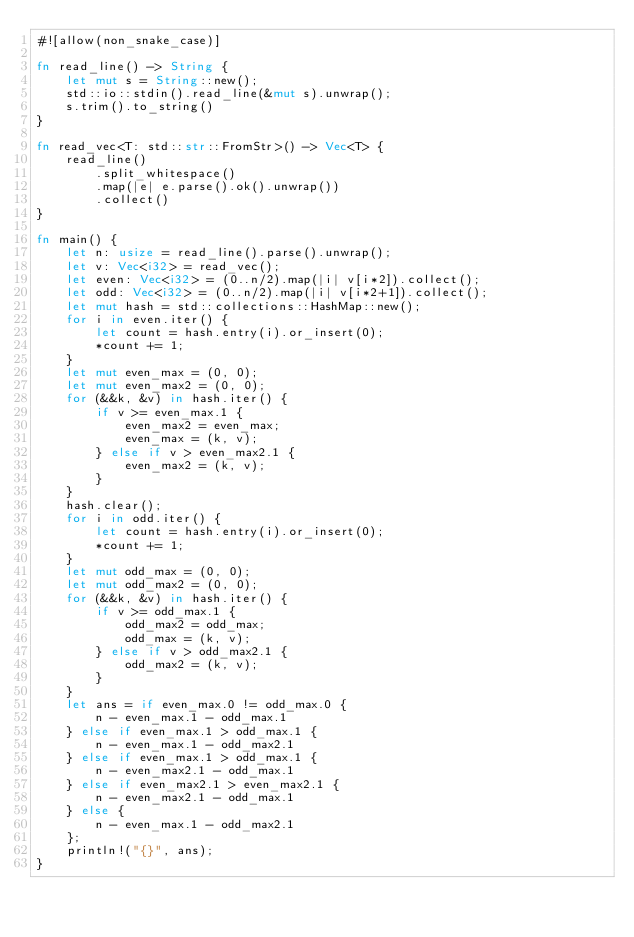<code> <loc_0><loc_0><loc_500><loc_500><_Rust_>#![allow(non_snake_case)]

fn read_line() -> String {
    let mut s = String::new();
    std::io::stdin().read_line(&mut s).unwrap();
    s.trim().to_string()
}

fn read_vec<T: std::str::FromStr>() -> Vec<T> {
    read_line()
        .split_whitespace()
        .map(|e| e.parse().ok().unwrap())
        .collect()
}

fn main() {
    let n: usize = read_line().parse().unwrap();
    let v: Vec<i32> = read_vec();
    let even: Vec<i32> = (0..n/2).map(|i| v[i*2]).collect();
    let odd: Vec<i32> = (0..n/2).map(|i| v[i*2+1]).collect();
    let mut hash = std::collections::HashMap::new();
    for i in even.iter() {
        let count = hash.entry(i).or_insert(0);
        *count += 1;
    }
    let mut even_max = (0, 0);
    let mut even_max2 = (0, 0);
    for (&&k, &v) in hash.iter() {
        if v >= even_max.1 {
            even_max2 = even_max;
            even_max = (k, v);
        } else if v > even_max2.1 {
            even_max2 = (k, v);
        }
    }
    hash.clear();
    for i in odd.iter() {
        let count = hash.entry(i).or_insert(0);
        *count += 1;
    }
    let mut odd_max = (0, 0);
    let mut odd_max2 = (0, 0);
    for (&&k, &v) in hash.iter() {
        if v >= odd_max.1 {
            odd_max2 = odd_max;
            odd_max = (k, v);
        } else if v > odd_max2.1 {
            odd_max2 = (k, v);
        }
    }
    let ans = if even_max.0 != odd_max.0 {
        n - even_max.1 - odd_max.1
    } else if even_max.1 > odd_max.1 {
        n - even_max.1 - odd_max2.1
    } else if even_max.1 > odd_max.1 {
        n - even_max2.1 - odd_max.1
    } else if even_max2.1 > even_max2.1 {
        n - even_max2.1 - odd_max.1
    } else {
        n - even_max.1 - odd_max2.1
    };
    println!("{}", ans);
}
</code> 